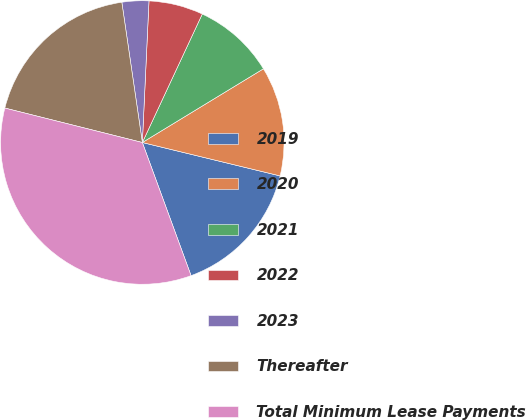Convert chart. <chart><loc_0><loc_0><loc_500><loc_500><pie_chart><fcel>2019<fcel>2020<fcel>2021<fcel>2022<fcel>2023<fcel>Thereafter<fcel>Total Minimum Lease Payments<nl><fcel>15.63%<fcel>12.49%<fcel>9.35%<fcel>6.2%<fcel>3.06%<fcel>18.78%<fcel>34.49%<nl></chart> 